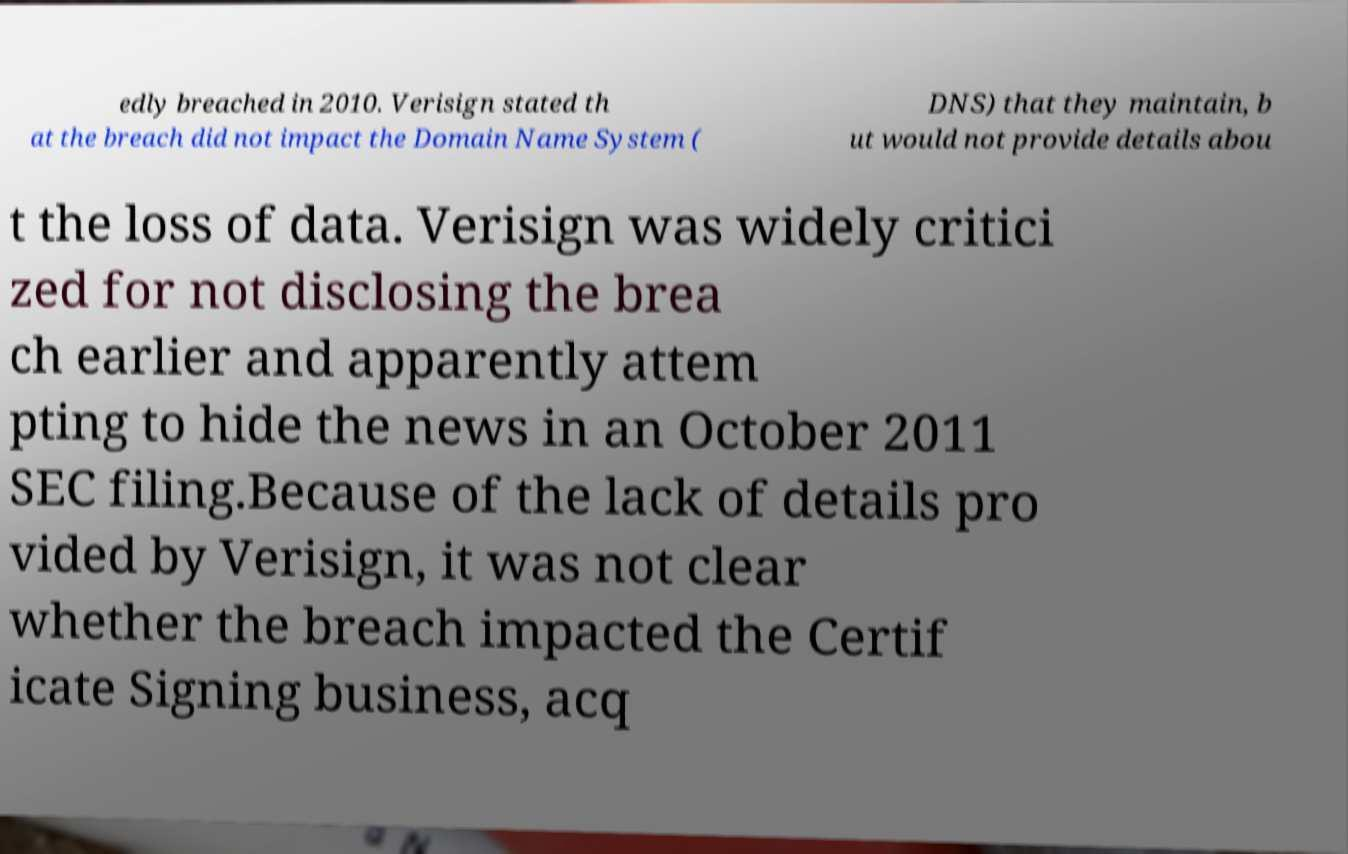Please read and relay the text visible in this image. What does it say? edly breached in 2010. Verisign stated th at the breach did not impact the Domain Name System ( DNS) that they maintain, b ut would not provide details abou t the loss of data. Verisign was widely critici zed for not disclosing the brea ch earlier and apparently attem pting to hide the news in an October 2011 SEC filing.Because of the lack of details pro vided by Verisign, it was not clear whether the breach impacted the Certif icate Signing business, acq 